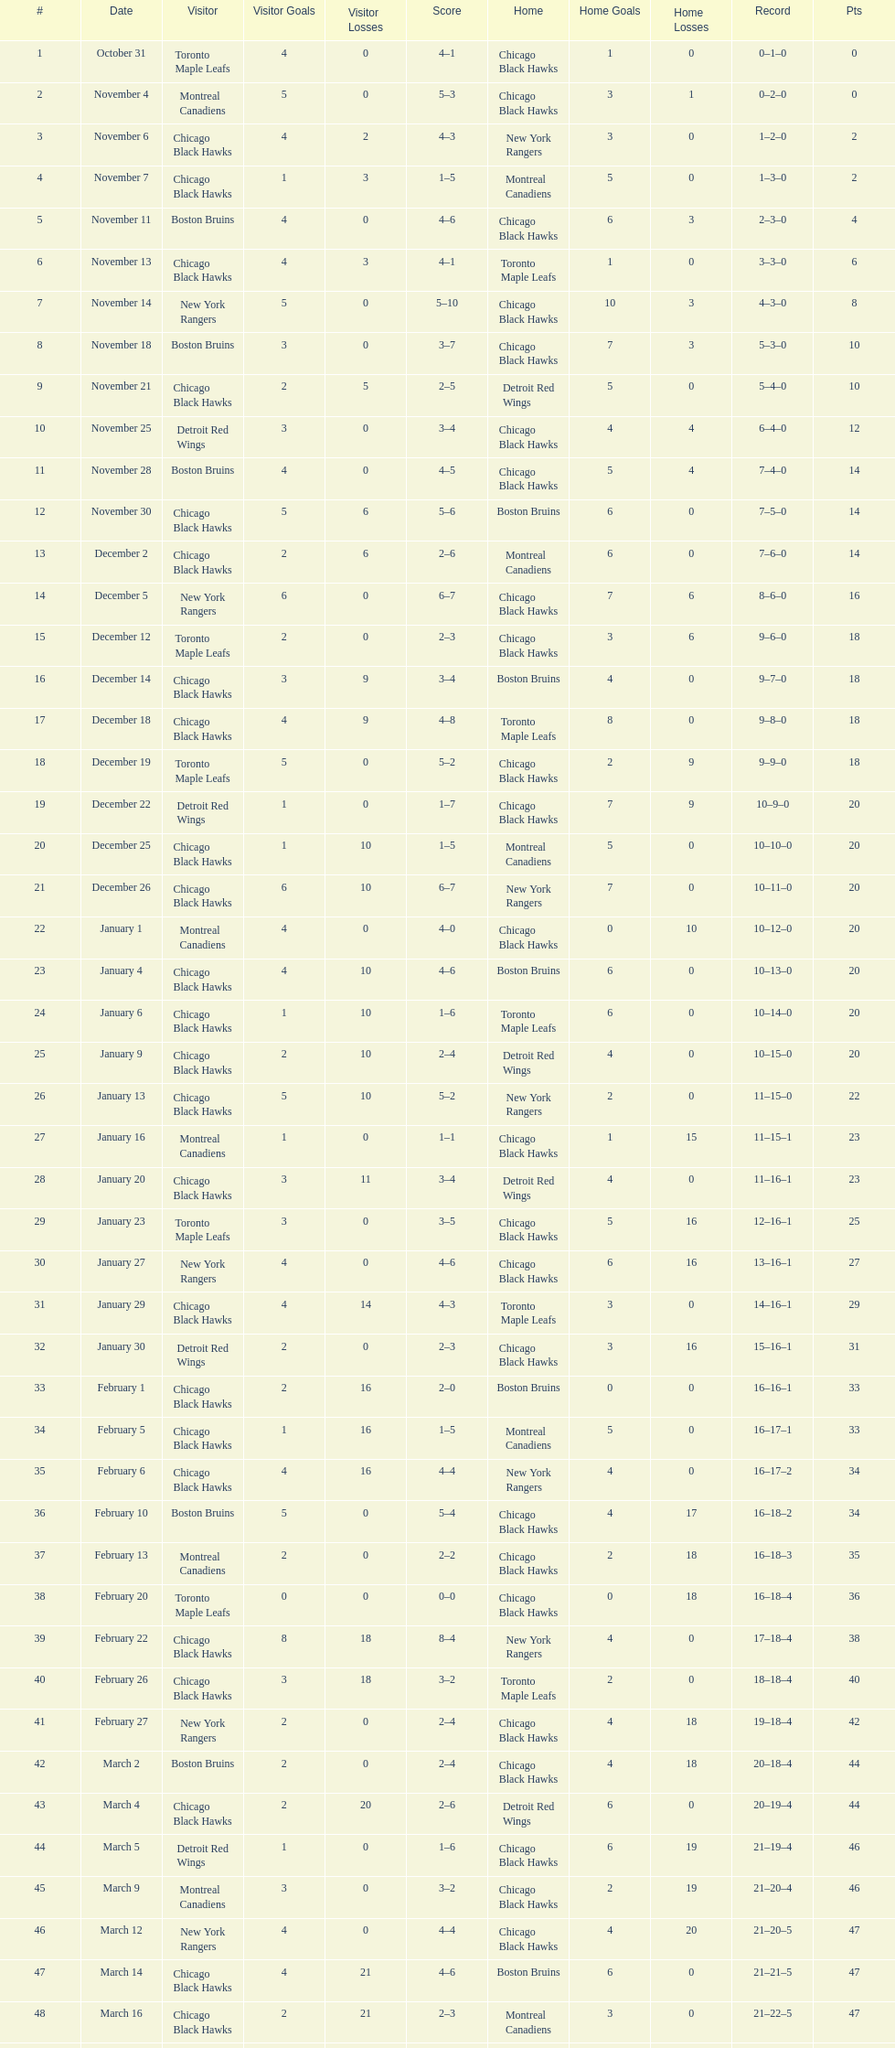Following november 11, who was the subsequent team to face the boston bruins? Chicago Black Hawks. 